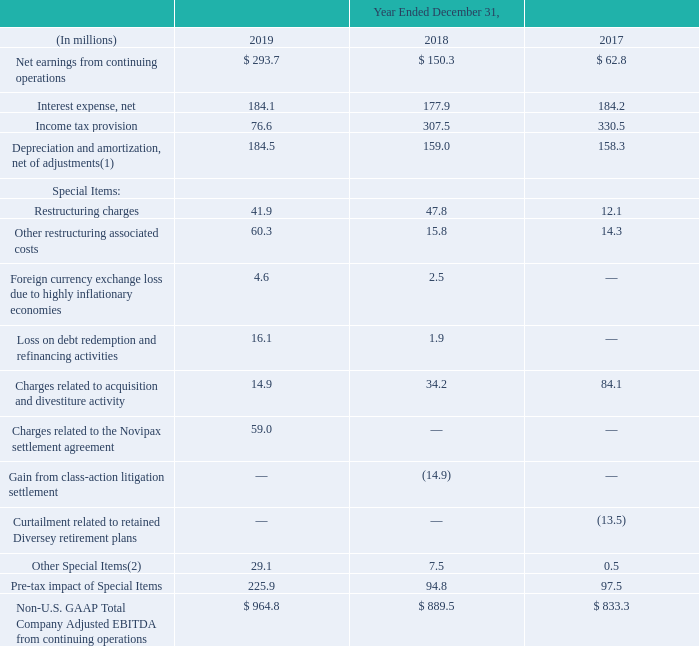Adjusted EBITDA is defined as Earnings before Interest Expense, Taxes, Depreciation and Amortization, adjusted to exclude the impact of Special Items. Management uses Adjusted EBITDA as one of many measures to assess the performance of the business. Additionally, Adjusted EBITDA is the performance metric used by the Company's chief operating decision maker to evaluate performance of our reportable segments. Adjusted EBITDA is also a metric used to determine performance in the Company's Annual Incentive Plan. We do not believe there are estimates underlying the calculation of Adjusted EBITDA, other than those inherent in our U.S. GAAP results of operations, which would render the use and presentation of Adjusted EBITDA misleading. While the nature and amount of individual Special Items vary from period to period, we believe our calculation of Adjusted EBITDA is applied consistently to all periods and, in conjunction with other U.S. GAAP and non- U.S. GAAP measures, provides a useful and consistent comparison of our Company's performance to other periods. In our evaluation of Adjusted EBITDA, management assumes that gain/losses related to Special Items may not be reflective of our core operating results.
(1) Includes depreciation and amortization adjustments of $(0.8) million and $(2.4) million for the years ended December 31, 2019 and 2018, respectively.
(2) Other Special Items for the years ended December 31, 2019 and 2018, primarily included fees related to professional services, mainly legal fees, directly associated with Special Items or events that are considered one-time or infrequent in nature.
The Company may also assess performance using Adjusted EBITDA Margin. Adjusted EBITDA Margin is calculated as Adjusted EBITDA divided by net trade sales. We believe that Adjusted EBITDA Margin is one useful measure to assess the profitability of sales made to third parties and the efficiency of our core operations.
The following table shows a reconciliation of U.S. GAAP Net Earnings from continuing operations to non-U.S. GAAP Total Company Adjusted EBITDA from continuing operations:
What is the definition of adjusted EBITDA? Adjusted ebitda is defined as earnings before interest expense, taxes, depreciation and amortization, adjusted to exclude the impact of special items. How is Adjusted EBITDA Margin calculated? Adjusted ebitda margin is calculated as adjusted ebitda divided by net trade sales. What is a reason for using Adjusted EBITDA Margin? Adjusted ebitda margin is one useful measure to assess the profitability of sales made to third parties and the efficiency of our core operations. What is the growth rate of Non-U.S. GAAP Total Company Adjusted EBITDA from continuing operations from year 2018 to year 2019?
Answer scale should be: percent. (964.8-889.5)/889.5
Answer: 8.47. What is the average annual Net earnings from continuing operations for 2017-2019? 
Answer scale should be: million. (293.7+150.3+62.8)/3
Answer: 168.93. What is the combined average annual cost of restructuring charges and other restructuring associated costs for years 2017-2019? 
Answer scale should be: million. (41.9+47.8+12.1+60.3+15.8+14.3)/3
Answer: 64.07. 